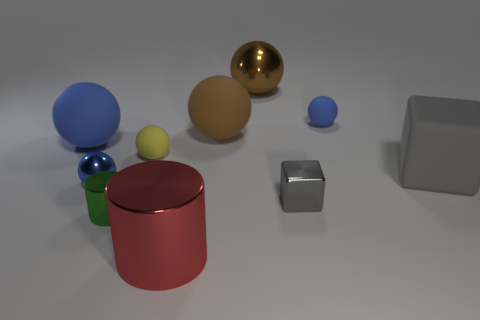There is a tiny sphere that is on the right side of the red thing that is in front of the tiny yellow object; what is its material?
Your answer should be very brief. Rubber. What shape is the large matte thing that is both in front of the brown rubber sphere and on the right side of the big blue object?
Give a very brief answer. Cube. How many other things are there of the same color as the big metal cylinder?
Keep it short and to the point. 0. How many things are large things on the left side of the large metallic sphere or metallic spheres?
Make the answer very short. 5. There is a small shiny block; is it the same color as the large object right of the small gray metal thing?
Keep it short and to the point. Yes. What size is the brown shiny thing to the left of the gray cube in front of the big gray cube?
Your answer should be very brief. Large. How many things are large gray metal spheres or small objects in front of the gray metallic thing?
Offer a terse response. 1. There is a large blue matte thing that is behind the tiny yellow rubber ball; is its shape the same as the brown matte object?
Ensure brevity in your answer.  Yes. There is a large matte thing that is left of the metallic object that is to the left of the tiny shiny cylinder; how many matte things are in front of it?
Keep it short and to the point. 2. What number of things are either tiny red blocks or big rubber blocks?
Your response must be concise. 1. 